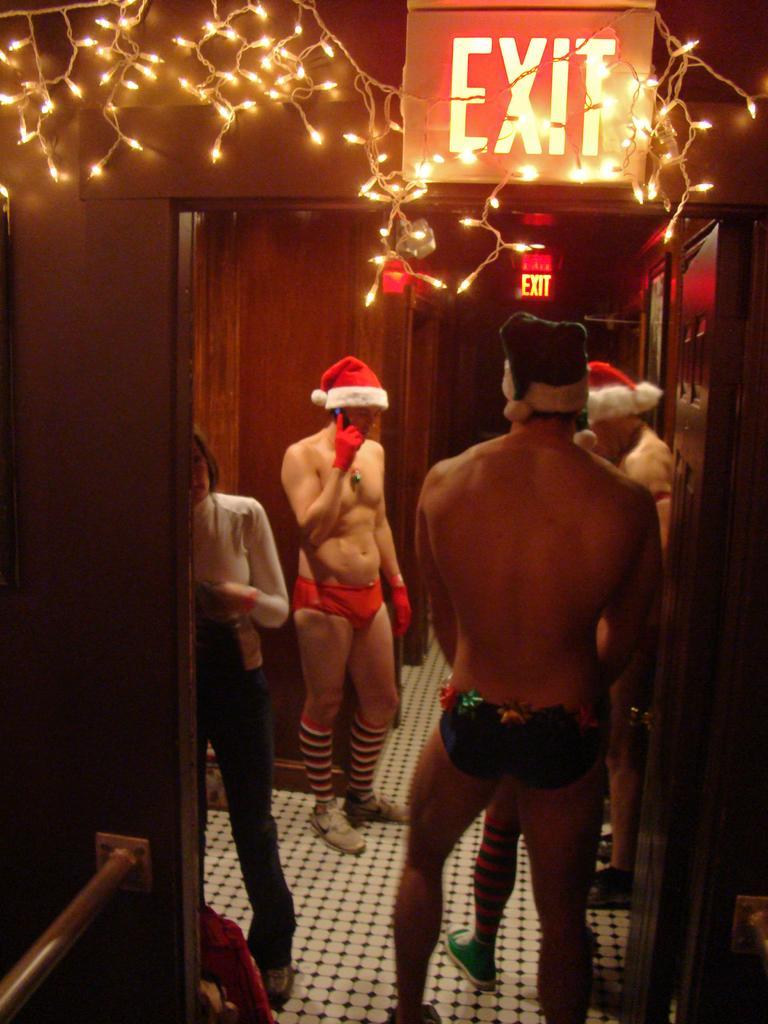Describe this image in one or two sentences. In this image, we can see some people standing and we can see the exit board, there are some lights and we can see the wall. 